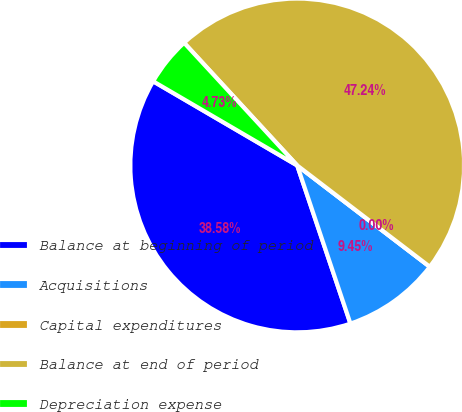<chart> <loc_0><loc_0><loc_500><loc_500><pie_chart><fcel>Balance at beginning of period<fcel>Acquisitions<fcel>Capital expenditures<fcel>Balance at end of period<fcel>Depreciation expense<nl><fcel>38.58%<fcel>9.45%<fcel>0.0%<fcel>47.24%<fcel>4.73%<nl></chart> 